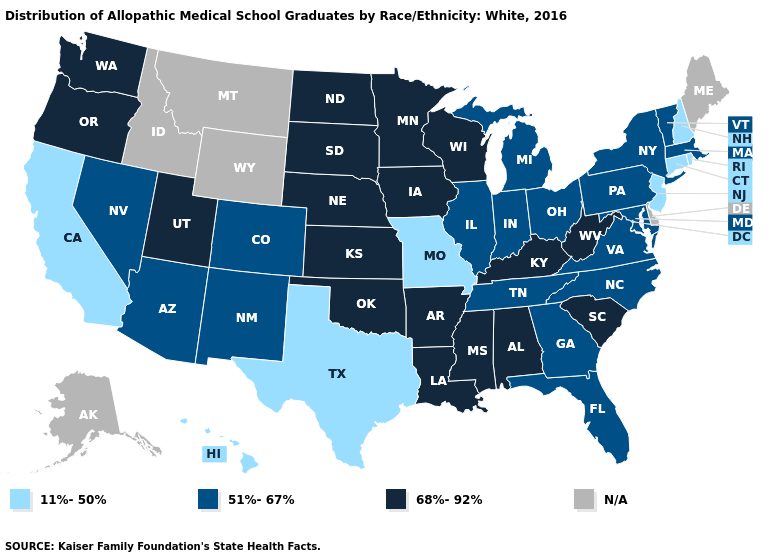What is the value of Delaware?
Be succinct. N/A. Name the states that have a value in the range 11%-50%?
Be succinct. California, Connecticut, Hawaii, Missouri, New Hampshire, New Jersey, Rhode Island, Texas. What is the value of Maine?
Give a very brief answer. N/A. Does Florida have the lowest value in the South?
Be succinct. No. Name the states that have a value in the range 51%-67%?
Quick response, please. Arizona, Colorado, Florida, Georgia, Illinois, Indiana, Maryland, Massachusetts, Michigan, Nevada, New Mexico, New York, North Carolina, Ohio, Pennsylvania, Tennessee, Vermont, Virginia. Does Oregon have the lowest value in the West?
Give a very brief answer. No. Which states have the lowest value in the South?
Be succinct. Texas. Name the states that have a value in the range 68%-92%?
Answer briefly. Alabama, Arkansas, Iowa, Kansas, Kentucky, Louisiana, Minnesota, Mississippi, Nebraska, North Dakota, Oklahoma, Oregon, South Carolina, South Dakota, Utah, Washington, West Virginia, Wisconsin. What is the value of Colorado?
Give a very brief answer. 51%-67%. What is the highest value in the South ?
Be succinct. 68%-92%. Name the states that have a value in the range N/A?
Keep it brief. Alaska, Delaware, Idaho, Maine, Montana, Wyoming. Among the states that border Alabama , does Mississippi have the highest value?
Give a very brief answer. Yes. What is the highest value in states that border Connecticut?
Answer briefly. 51%-67%. Name the states that have a value in the range 51%-67%?
Short answer required. Arizona, Colorado, Florida, Georgia, Illinois, Indiana, Maryland, Massachusetts, Michigan, Nevada, New Mexico, New York, North Carolina, Ohio, Pennsylvania, Tennessee, Vermont, Virginia. 